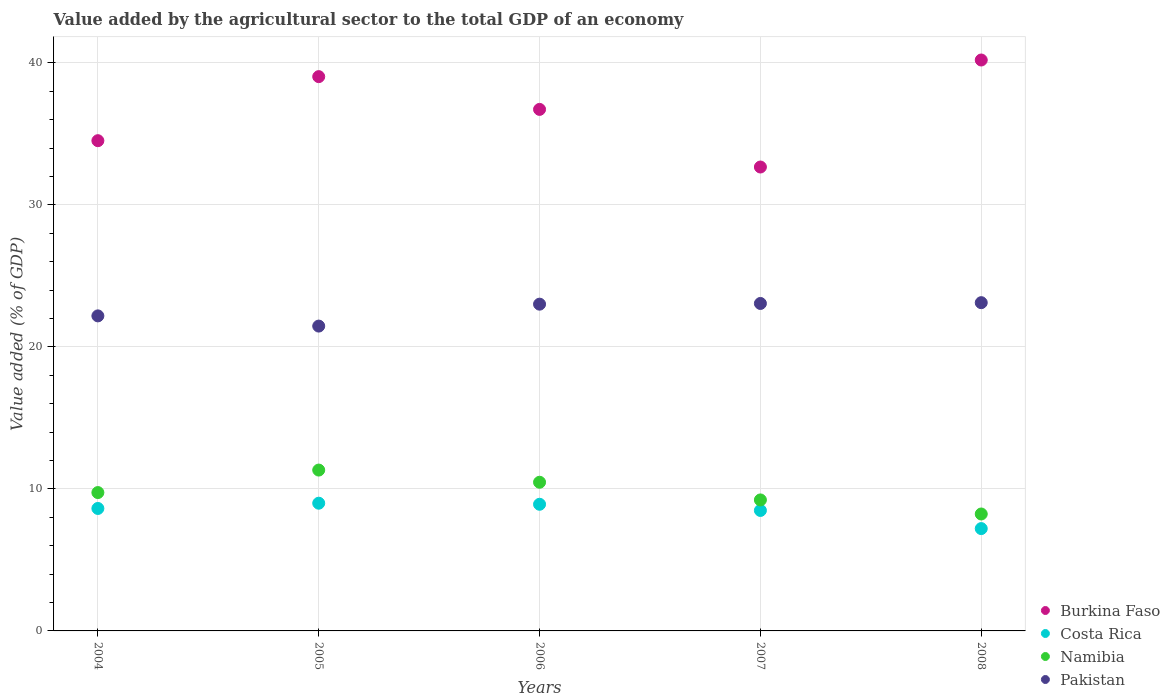How many different coloured dotlines are there?
Provide a succinct answer. 4. Is the number of dotlines equal to the number of legend labels?
Offer a very short reply. Yes. What is the value added by the agricultural sector to the total GDP in Namibia in 2004?
Make the answer very short. 9.74. Across all years, what is the maximum value added by the agricultural sector to the total GDP in Pakistan?
Make the answer very short. 23.11. Across all years, what is the minimum value added by the agricultural sector to the total GDP in Burkina Faso?
Offer a very short reply. 32.67. In which year was the value added by the agricultural sector to the total GDP in Namibia minimum?
Make the answer very short. 2008. What is the total value added by the agricultural sector to the total GDP in Burkina Faso in the graph?
Make the answer very short. 183.14. What is the difference between the value added by the agricultural sector to the total GDP in Burkina Faso in 2007 and that in 2008?
Offer a terse response. -7.54. What is the difference between the value added by the agricultural sector to the total GDP in Burkina Faso in 2008 and the value added by the agricultural sector to the total GDP in Pakistan in 2007?
Make the answer very short. 17.14. What is the average value added by the agricultural sector to the total GDP in Pakistan per year?
Give a very brief answer. 22.57. In the year 2006, what is the difference between the value added by the agricultural sector to the total GDP in Pakistan and value added by the agricultural sector to the total GDP in Costa Rica?
Your response must be concise. 14.09. In how many years, is the value added by the agricultural sector to the total GDP in Costa Rica greater than 38 %?
Your answer should be compact. 0. What is the ratio of the value added by the agricultural sector to the total GDP in Burkina Faso in 2006 to that in 2008?
Your answer should be very brief. 0.91. Is the value added by the agricultural sector to the total GDP in Namibia in 2005 less than that in 2007?
Your answer should be compact. No. What is the difference between the highest and the second highest value added by the agricultural sector to the total GDP in Pakistan?
Provide a succinct answer. 0.06. What is the difference between the highest and the lowest value added by the agricultural sector to the total GDP in Namibia?
Offer a very short reply. 3.09. Is the value added by the agricultural sector to the total GDP in Costa Rica strictly less than the value added by the agricultural sector to the total GDP in Pakistan over the years?
Your answer should be compact. Yes. What is the difference between two consecutive major ticks on the Y-axis?
Keep it short and to the point. 10. Are the values on the major ticks of Y-axis written in scientific E-notation?
Provide a short and direct response. No. Does the graph contain grids?
Your answer should be very brief. Yes. How are the legend labels stacked?
Provide a succinct answer. Vertical. What is the title of the graph?
Your answer should be compact. Value added by the agricultural sector to the total GDP of an economy. What is the label or title of the Y-axis?
Make the answer very short. Value added (% of GDP). What is the Value added (% of GDP) in Burkina Faso in 2004?
Provide a succinct answer. 34.52. What is the Value added (% of GDP) of Costa Rica in 2004?
Keep it short and to the point. 8.62. What is the Value added (% of GDP) of Namibia in 2004?
Keep it short and to the point. 9.74. What is the Value added (% of GDP) of Pakistan in 2004?
Keep it short and to the point. 22.18. What is the Value added (% of GDP) of Burkina Faso in 2005?
Your response must be concise. 39.03. What is the Value added (% of GDP) in Costa Rica in 2005?
Offer a terse response. 8.99. What is the Value added (% of GDP) in Namibia in 2005?
Provide a succinct answer. 11.33. What is the Value added (% of GDP) of Pakistan in 2005?
Ensure brevity in your answer.  21.47. What is the Value added (% of GDP) in Burkina Faso in 2006?
Your answer should be very brief. 36.72. What is the Value added (% of GDP) in Costa Rica in 2006?
Provide a succinct answer. 8.92. What is the Value added (% of GDP) in Namibia in 2006?
Make the answer very short. 10.47. What is the Value added (% of GDP) of Pakistan in 2006?
Your response must be concise. 23.01. What is the Value added (% of GDP) of Burkina Faso in 2007?
Make the answer very short. 32.67. What is the Value added (% of GDP) of Costa Rica in 2007?
Offer a terse response. 8.48. What is the Value added (% of GDP) in Namibia in 2007?
Provide a short and direct response. 9.22. What is the Value added (% of GDP) in Pakistan in 2007?
Keep it short and to the point. 23.06. What is the Value added (% of GDP) in Burkina Faso in 2008?
Offer a very short reply. 40.2. What is the Value added (% of GDP) of Costa Rica in 2008?
Provide a succinct answer. 7.21. What is the Value added (% of GDP) in Namibia in 2008?
Keep it short and to the point. 8.23. What is the Value added (% of GDP) of Pakistan in 2008?
Ensure brevity in your answer.  23.11. Across all years, what is the maximum Value added (% of GDP) of Burkina Faso?
Your answer should be very brief. 40.2. Across all years, what is the maximum Value added (% of GDP) of Costa Rica?
Give a very brief answer. 8.99. Across all years, what is the maximum Value added (% of GDP) of Namibia?
Keep it short and to the point. 11.33. Across all years, what is the maximum Value added (% of GDP) in Pakistan?
Ensure brevity in your answer.  23.11. Across all years, what is the minimum Value added (% of GDP) of Burkina Faso?
Keep it short and to the point. 32.67. Across all years, what is the minimum Value added (% of GDP) of Costa Rica?
Provide a succinct answer. 7.21. Across all years, what is the minimum Value added (% of GDP) in Namibia?
Offer a terse response. 8.23. Across all years, what is the minimum Value added (% of GDP) in Pakistan?
Ensure brevity in your answer.  21.47. What is the total Value added (% of GDP) in Burkina Faso in the graph?
Give a very brief answer. 183.14. What is the total Value added (% of GDP) of Costa Rica in the graph?
Your response must be concise. 42.22. What is the total Value added (% of GDP) of Namibia in the graph?
Provide a succinct answer. 49. What is the total Value added (% of GDP) of Pakistan in the graph?
Your answer should be compact. 112.83. What is the difference between the Value added (% of GDP) of Burkina Faso in 2004 and that in 2005?
Ensure brevity in your answer.  -4.51. What is the difference between the Value added (% of GDP) of Costa Rica in 2004 and that in 2005?
Your response must be concise. -0.37. What is the difference between the Value added (% of GDP) in Namibia in 2004 and that in 2005?
Your response must be concise. -1.58. What is the difference between the Value added (% of GDP) in Pakistan in 2004 and that in 2005?
Offer a very short reply. 0.72. What is the difference between the Value added (% of GDP) of Burkina Faso in 2004 and that in 2006?
Provide a short and direct response. -2.2. What is the difference between the Value added (% of GDP) of Costa Rica in 2004 and that in 2006?
Your answer should be very brief. -0.29. What is the difference between the Value added (% of GDP) of Namibia in 2004 and that in 2006?
Ensure brevity in your answer.  -0.73. What is the difference between the Value added (% of GDP) of Pakistan in 2004 and that in 2006?
Provide a short and direct response. -0.83. What is the difference between the Value added (% of GDP) of Burkina Faso in 2004 and that in 2007?
Ensure brevity in your answer.  1.85. What is the difference between the Value added (% of GDP) of Costa Rica in 2004 and that in 2007?
Provide a succinct answer. 0.14. What is the difference between the Value added (% of GDP) of Namibia in 2004 and that in 2007?
Give a very brief answer. 0.52. What is the difference between the Value added (% of GDP) in Pakistan in 2004 and that in 2007?
Offer a very short reply. -0.87. What is the difference between the Value added (% of GDP) in Burkina Faso in 2004 and that in 2008?
Ensure brevity in your answer.  -5.68. What is the difference between the Value added (% of GDP) in Costa Rica in 2004 and that in 2008?
Offer a very short reply. 1.42. What is the difference between the Value added (% of GDP) in Namibia in 2004 and that in 2008?
Make the answer very short. 1.51. What is the difference between the Value added (% of GDP) of Pakistan in 2004 and that in 2008?
Your answer should be compact. -0.93. What is the difference between the Value added (% of GDP) in Burkina Faso in 2005 and that in 2006?
Ensure brevity in your answer.  2.31. What is the difference between the Value added (% of GDP) in Costa Rica in 2005 and that in 2006?
Provide a short and direct response. 0.08. What is the difference between the Value added (% of GDP) in Namibia in 2005 and that in 2006?
Ensure brevity in your answer.  0.86. What is the difference between the Value added (% of GDP) of Pakistan in 2005 and that in 2006?
Offer a very short reply. -1.54. What is the difference between the Value added (% of GDP) in Burkina Faso in 2005 and that in 2007?
Your answer should be compact. 6.36. What is the difference between the Value added (% of GDP) of Costa Rica in 2005 and that in 2007?
Give a very brief answer. 0.51. What is the difference between the Value added (% of GDP) in Namibia in 2005 and that in 2007?
Provide a succinct answer. 2.1. What is the difference between the Value added (% of GDP) of Pakistan in 2005 and that in 2007?
Give a very brief answer. -1.59. What is the difference between the Value added (% of GDP) of Burkina Faso in 2005 and that in 2008?
Your answer should be very brief. -1.17. What is the difference between the Value added (% of GDP) in Costa Rica in 2005 and that in 2008?
Your answer should be compact. 1.79. What is the difference between the Value added (% of GDP) in Namibia in 2005 and that in 2008?
Offer a very short reply. 3.09. What is the difference between the Value added (% of GDP) of Pakistan in 2005 and that in 2008?
Offer a terse response. -1.65. What is the difference between the Value added (% of GDP) of Burkina Faso in 2006 and that in 2007?
Make the answer very short. 4.06. What is the difference between the Value added (% of GDP) in Costa Rica in 2006 and that in 2007?
Give a very brief answer. 0.44. What is the difference between the Value added (% of GDP) in Namibia in 2006 and that in 2007?
Provide a succinct answer. 1.24. What is the difference between the Value added (% of GDP) in Pakistan in 2006 and that in 2007?
Your answer should be very brief. -0.05. What is the difference between the Value added (% of GDP) of Burkina Faso in 2006 and that in 2008?
Keep it short and to the point. -3.48. What is the difference between the Value added (% of GDP) in Costa Rica in 2006 and that in 2008?
Your response must be concise. 1.71. What is the difference between the Value added (% of GDP) of Namibia in 2006 and that in 2008?
Offer a very short reply. 2.24. What is the difference between the Value added (% of GDP) in Pakistan in 2006 and that in 2008?
Your answer should be compact. -0.1. What is the difference between the Value added (% of GDP) of Burkina Faso in 2007 and that in 2008?
Give a very brief answer. -7.54. What is the difference between the Value added (% of GDP) of Costa Rica in 2007 and that in 2008?
Your answer should be very brief. 1.28. What is the difference between the Value added (% of GDP) of Pakistan in 2007 and that in 2008?
Make the answer very short. -0.06. What is the difference between the Value added (% of GDP) of Burkina Faso in 2004 and the Value added (% of GDP) of Costa Rica in 2005?
Provide a succinct answer. 25.53. What is the difference between the Value added (% of GDP) in Burkina Faso in 2004 and the Value added (% of GDP) in Namibia in 2005?
Your answer should be compact. 23.19. What is the difference between the Value added (% of GDP) in Burkina Faso in 2004 and the Value added (% of GDP) in Pakistan in 2005?
Ensure brevity in your answer.  13.06. What is the difference between the Value added (% of GDP) of Costa Rica in 2004 and the Value added (% of GDP) of Namibia in 2005?
Provide a short and direct response. -2.7. What is the difference between the Value added (% of GDP) in Costa Rica in 2004 and the Value added (% of GDP) in Pakistan in 2005?
Give a very brief answer. -12.84. What is the difference between the Value added (% of GDP) in Namibia in 2004 and the Value added (% of GDP) in Pakistan in 2005?
Provide a succinct answer. -11.72. What is the difference between the Value added (% of GDP) in Burkina Faso in 2004 and the Value added (% of GDP) in Costa Rica in 2006?
Ensure brevity in your answer.  25.6. What is the difference between the Value added (% of GDP) in Burkina Faso in 2004 and the Value added (% of GDP) in Namibia in 2006?
Provide a succinct answer. 24.05. What is the difference between the Value added (% of GDP) of Burkina Faso in 2004 and the Value added (% of GDP) of Pakistan in 2006?
Offer a terse response. 11.51. What is the difference between the Value added (% of GDP) of Costa Rica in 2004 and the Value added (% of GDP) of Namibia in 2006?
Provide a short and direct response. -1.85. What is the difference between the Value added (% of GDP) of Costa Rica in 2004 and the Value added (% of GDP) of Pakistan in 2006?
Offer a very short reply. -14.39. What is the difference between the Value added (% of GDP) of Namibia in 2004 and the Value added (% of GDP) of Pakistan in 2006?
Your response must be concise. -13.27. What is the difference between the Value added (% of GDP) of Burkina Faso in 2004 and the Value added (% of GDP) of Costa Rica in 2007?
Your answer should be very brief. 26.04. What is the difference between the Value added (% of GDP) of Burkina Faso in 2004 and the Value added (% of GDP) of Namibia in 2007?
Your answer should be very brief. 25.3. What is the difference between the Value added (% of GDP) of Burkina Faso in 2004 and the Value added (% of GDP) of Pakistan in 2007?
Provide a succinct answer. 11.46. What is the difference between the Value added (% of GDP) in Costa Rica in 2004 and the Value added (% of GDP) in Namibia in 2007?
Provide a succinct answer. -0.6. What is the difference between the Value added (% of GDP) of Costa Rica in 2004 and the Value added (% of GDP) of Pakistan in 2007?
Ensure brevity in your answer.  -14.44. What is the difference between the Value added (% of GDP) of Namibia in 2004 and the Value added (% of GDP) of Pakistan in 2007?
Your response must be concise. -13.32. What is the difference between the Value added (% of GDP) in Burkina Faso in 2004 and the Value added (% of GDP) in Costa Rica in 2008?
Ensure brevity in your answer.  27.32. What is the difference between the Value added (% of GDP) of Burkina Faso in 2004 and the Value added (% of GDP) of Namibia in 2008?
Provide a short and direct response. 26.29. What is the difference between the Value added (% of GDP) in Burkina Faso in 2004 and the Value added (% of GDP) in Pakistan in 2008?
Your answer should be compact. 11.41. What is the difference between the Value added (% of GDP) in Costa Rica in 2004 and the Value added (% of GDP) in Namibia in 2008?
Make the answer very short. 0.39. What is the difference between the Value added (% of GDP) of Costa Rica in 2004 and the Value added (% of GDP) of Pakistan in 2008?
Your response must be concise. -14.49. What is the difference between the Value added (% of GDP) of Namibia in 2004 and the Value added (% of GDP) of Pakistan in 2008?
Give a very brief answer. -13.37. What is the difference between the Value added (% of GDP) of Burkina Faso in 2005 and the Value added (% of GDP) of Costa Rica in 2006?
Ensure brevity in your answer.  30.11. What is the difference between the Value added (% of GDP) of Burkina Faso in 2005 and the Value added (% of GDP) of Namibia in 2006?
Offer a very short reply. 28.56. What is the difference between the Value added (% of GDP) of Burkina Faso in 2005 and the Value added (% of GDP) of Pakistan in 2006?
Your response must be concise. 16.02. What is the difference between the Value added (% of GDP) in Costa Rica in 2005 and the Value added (% of GDP) in Namibia in 2006?
Provide a succinct answer. -1.48. What is the difference between the Value added (% of GDP) in Costa Rica in 2005 and the Value added (% of GDP) in Pakistan in 2006?
Make the answer very short. -14.02. What is the difference between the Value added (% of GDP) of Namibia in 2005 and the Value added (% of GDP) of Pakistan in 2006?
Your answer should be compact. -11.68. What is the difference between the Value added (% of GDP) of Burkina Faso in 2005 and the Value added (% of GDP) of Costa Rica in 2007?
Give a very brief answer. 30.55. What is the difference between the Value added (% of GDP) in Burkina Faso in 2005 and the Value added (% of GDP) in Namibia in 2007?
Keep it short and to the point. 29.81. What is the difference between the Value added (% of GDP) of Burkina Faso in 2005 and the Value added (% of GDP) of Pakistan in 2007?
Provide a short and direct response. 15.97. What is the difference between the Value added (% of GDP) of Costa Rica in 2005 and the Value added (% of GDP) of Namibia in 2007?
Provide a short and direct response. -0.23. What is the difference between the Value added (% of GDP) of Costa Rica in 2005 and the Value added (% of GDP) of Pakistan in 2007?
Make the answer very short. -14.06. What is the difference between the Value added (% of GDP) of Namibia in 2005 and the Value added (% of GDP) of Pakistan in 2007?
Provide a short and direct response. -11.73. What is the difference between the Value added (% of GDP) in Burkina Faso in 2005 and the Value added (% of GDP) in Costa Rica in 2008?
Your response must be concise. 31.83. What is the difference between the Value added (% of GDP) in Burkina Faso in 2005 and the Value added (% of GDP) in Namibia in 2008?
Keep it short and to the point. 30.8. What is the difference between the Value added (% of GDP) of Burkina Faso in 2005 and the Value added (% of GDP) of Pakistan in 2008?
Offer a terse response. 15.92. What is the difference between the Value added (% of GDP) of Costa Rica in 2005 and the Value added (% of GDP) of Namibia in 2008?
Keep it short and to the point. 0.76. What is the difference between the Value added (% of GDP) in Costa Rica in 2005 and the Value added (% of GDP) in Pakistan in 2008?
Offer a terse response. -14.12. What is the difference between the Value added (% of GDP) in Namibia in 2005 and the Value added (% of GDP) in Pakistan in 2008?
Provide a short and direct response. -11.79. What is the difference between the Value added (% of GDP) in Burkina Faso in 2006 and the Value added (% of GDP) in Costa Rica in 2007?
Offer a terse response. 28.24. What is the difference between the Value added (% of GDP) in Burkina Faso in 2006 and the Value added (% of GDP) in Namibia in 2007?
Make the answer very short. 27.5. What is the difference between the Value added (% of GDP) in Burkina Faso in 2006 and the Value added (% of GDP) in Pakistan in 2007?
Provide a succinct answer. 13.67. What is the difference between the Value added (% of GDP) of Costa Rica in 2006 and the Value added (% of GDP) of Namibia in 2007?
Provide a short and direct response. -0.31. What is the difference between the Value added (% of GDP) in Costa Rica in 2006 and the Value added (% of GDP) in Pakistan in 2007?
Your answer should be very brief. -14.14. What is the difference between the Value added (% of GDP) in Namibia in 2006 and the Value added (% of GDP) in Pakistan in 2007?
Your response must be concise. -12.59. What is the difference between the Value added (% of GDP) in Burkina Faso in 2006 and the Value added (% of GDP) in Costa Rica in 2008?
Give a very brief answer. 29.52. What is the difference between the Value added (% of GDP) in Burkina Faso in 2006 and the Value added (% of GDP) in Namibia in 2008?
Your response must be concise. 28.49. What is the difference between the Value added (% of GDP) of Burkina Faso in 2006 and the Value added (% of GDP) of Pakistan in 2008?
Your answer should be compact. 13.61. What is the difference between the Value added (% of GDP) of Costa Rica in 2006 and the Value added (% of GDP) of Namibia in 2008?
Provide a succinct answer. 0.68. What is the difference between the Value added (% of GDP) in Costa Rica in 2006 and the Value added (% of GDP) in Pakistan in 2008?
Make the answer very short. -14.2. What is the difference between the Value added (% of GDP) in Namibia in 2006 and the Value added (% of GDP) in Pakistan in 2008?
Provide a succinct answer. -12.65. What is the difference between the Value added (% of GDP) of Burkina Faso in 2007 and the Value added (% of GDP) of Costa Rica in 2008?
Offer a very short reply. 25.46. What is the difference between the Value added (% of GDP) of Burkina Faso in 2007 and the Value added (% of GDP) of Namibia in 2008?
Give a very brief answer. 24.43. What is the difference between the Value added (% of GDP) of Burkina Faso in 2007 and the Value added (% of GDP) of Pakistan in 2008?
Provide a succinct answer. 9.55. What is the difference between the Value added (% of GDP) of Costa Rica in 2007 and the Value added (% of GDP) of Namibia in 2008?
Keep it short and to the point. 0.25. What is the difference between the Value added (% of GDP) of Costa Rica in 2007 and the Value added (% of GDP) of Pakistan in 2008?
Your answer should be compact. -14.63. What is the difference between the Value added (% of GDP) in Namibia in 2007 and the Value added (% of GDP) in Pakistan in 2008?
Offer a terse response. -13.89. What is the average Value added (% of GDP) in Burkina Faso per year?
Ensure brevity in your answer.  36.63. What is the average Value added (% of GDP) in Costa Rica per year?
Your response must be concise. 8.44. What is the average Value added (% of GDP) of Namibia per year?
Provide a succinct answer. 9.8. What is the average Value added (% of GDP) of Pakistan per year?
Ensure brevity in your answer.  22.57. In the year 2004, what is the difference between the Value added (% of GDP) in Burkina Faso and Value added (% of GDP) in Costa Rica?
Keep it short and to the point. 25.9. In the year 2004, what is the difference between the Value added (% of GDP) of Burkina Faso and Value added (% of GDP) of Namibia?
Keep it short and to the point. 24.78. In the year 2004, what is the difference between the Value added (% of GDP) of Burkina Faso and Value added (% of GDP) of Pakistan?
Offer a terse response. 12.34. In the year 2004, what is the difference between the Value added (% of GDP) in Costa Rica and Value added (% of GDP) in Namibia?
Provide a succinct answer. -1.12. In the year 2004, what is the difference between the Value added (% of GDP) in Costa Rica and Value added (% of GDP) in Pakistan?
Make the answer very short. -13.56. In the year 2004, what is the difference between the Value added (% of GDP) of Namibia and Value added (% of GDP) of Pakistan?
Offer a very short reply. -12.44. In the year 2005, what is the difference between the Value added (% of GDP) of Burkina Faso and Value added (% of GDP) of Costa Rica?
Offer a very short reply. 30.04. In the year 2005, what is the difference between the Value added (% of GDP) in Burkina Faso and Value added (% of GDP) in Namibia?
Offer a terse response. 27.7. In the year 2005, what is the difference between the Value added (% of GDP) in Burkina Faso and Value added (% of GDP) in Pakistan?
Keep it short and to the point. 17.57. In the year 2005, what is the difference between the Value added (% of GDP) in Costa Rica and Value added (% of GDP) in Namibia?
Offer a very short reply. -2.33. In the year 2005, what is the difference between the Value added (% of GDP) in Costa Rica and Value added (% of GDP) in Pakistan?
Make the answer very short. -12.47. In the year 2005, what is the difference between the Value added (% of GDP) of Namibia and Value added (% of GDP) of Pakistan?
Your response must be concise. -10.14. In the year 2006, what is the difference between the Value added (% of GDP) of Burkina Faso and Value added (% of GDP) of Costa Rica?
Offer a terse response. 27.81. In the year 2006, what is the difference between the Value added (% of GDP) of Burkina Faso and Value added (% of GDP) of Namibia?
Keep it short and to the point. 26.25. In the year 2006, what is the difference between the Value added (% of GDP) in Burkina Faso and Value added (% of GDP) in Pakistan?
Provide a succinct answer. 13.71. In the year 2006, what is the difference between the Value added (% of GDP) of Costa Rica and Value added (% of GDP) of Namibia?
Keep it short and to the point. -1.55. In the year 2006, what is the difference between the Value added (% of GDP) in Costa Rica and Value added (% of GDP) in Pakistan?
Offer a terse response. -14.09. In the year 2006, what is the difference between the Value added (% of GDP) of Namibia and Value added (% of GDP) of Pakistan?
Your response must be concise. -12.54. In the year 2007, what is the difference between the Value added (% of GDP) of Burkina Faso and Value added (% of GDP) of Costa Rica?
Provide a short and direct response. 24.18. In the year 2007, what is the difference between the Value added (% of GDP) of Burkina Faso and Value added (% of GDP) of Namibia?
Offer a very short reply. 23.44. In the year 2007, what is the difference between the Value added (% of GDP) of Burkina Faso and Value added (% of GDP) of Pakistan?
Your answer should be compact. 9.61. In the year 2007, what is the difference between the Value added (% of GDP) of Costa Rica and Value added (% of GDP) of Namibia?
Give a very brief answer. -0.74. In the year 2007, what is the difference between the Value added (% of GDP) of Costa Rica and Value added (% of GDP) of Pakistan?
Make the answer very short. -14.58. In the year 2007, what is the difference between the Value added (% of GDP) of Namibia and Value added (% of GDP) of Pakistan?
Provide a short and direct response. -13.83. In the year 2008, what is the difference between the Value added (% of GDP) in Burkina Faso and Value added (% of GDP) in Costa Rica?
Offer a terse response. 33. In the year 2008, what is the difference between the Value added (% of GDP) of Burkina Faso and Value added (% of GDP) of Namibia?
Your response must be concise. 31.97. In the year 2008, what is the difference between the Value added (% of GDP) of Burkina Faso and Value added (% of GDP) of Pakistan?
Keep it short and to the point. 17.09. In the year 2008, what is the difference between the Value added (% of GDP) in Costa Rica and Value added (% of GDP) in Namibia?
Your answer should be compact. -1.03. In the year 2008, what is the difference between the Value added (% of GDP) of Costa Rica and Value added (% of GDP) of Pakistan?
Your answer should be compact. -15.91. In the year 2008, what is the difference between the Value added (% of GDP) of Namibia and Value added (% of GDP) of Pakistan?
Keep it short and to the point. -14.88. What is the ratio of the Value added (% of GDP) in Burkina Faso in 2004 to that in 2005?
Your answer should be compact. 0.88. What is the ratio of the Value added (% of GDP) of Costa Rica in 2004 to that in 2005?
Provide a short and direct response. 0.96. What is the ratio of the Value added (% of GDP) of Namibia in 2004 to that in 2005?
Your response must be concise. 0.86. What is the ratio of the Value added (% of GDP) of Pakistan in 2004 to that in 2005?
Offer a terse response. 1.03. What is the ratio of the Value added (% of GDP) of Burkina Faso in 2004 to that in 2006?
Provide a short and direct response. 0.94. What is the ratio of the Value added (% of GDP) in Namibia in 2004 to that in 2006?
Offer a very short reply. 0.93. What is the ratio of the Value added (% of GDP) of Pakistan in 2004 to that in 2006?
Give a very brief answer. 0.96. What is the ratio of the Value added (% of GDP) of Burkina Faso in 2004 to that in 2007?
Offer a terse response. 1.06. What is the ratio of the Value added (% of GDP) in Costa Rica in 2004 to that in 2007?
Offer a terse response. 1.02. What is the ratio of the Value added (% of GDP) in Namibia in 2004 to that in 2007?
Make the answer very short. 1.06. What is the ratio of the Value added (% of GDP) in Pakistan in 2004 to that in 2007?
Provide a short and direct response. 0.96. What is the ratio of the Value added (% of GDP) in Burkina Faso in 2004 to that in 2008?
Provide a short and direct response. 0.86. What is the ratio of the Value added (% of GDP) of Costa Rica in 2004 to that in 2008?
Provide a short and direct response. 1.2. What is the ratio of the Value added (% of GDP) of Namibia in 2004 to that in 2008?
Give a very brief answer. 1.18. What is the ratio of the Value added (% of GDP) of Pakistan in 2004 to that in 2008?
Provide a short and direct response. 0.96. What is the ratio of the Value added (% of GDP) of Burkina Faso in 2005 to that in 2006?
Provide a short and direct response. 1.06. What is the ratio of the Value added (% of GDP) of Costa Rica in 2005 to that in 2006?
Your answer should be compact. 1.01. What is the ratio of the Value added (% of GDP) of Namibia in 2005 to that in 2006?
Your response must be concise. 1.08. What is the ratio of the Value added (% of GDP) in Pakistan in 2005 to that in 2006?
Ensure brevity in your answer.  0.93. What is the ratio of the Value added (% of GDP) in Burkina Faso in 2005 to that in 2007?
Ensure brevity in your answer.  1.19. What is the ratio of the Value added (% of GDP) of Costa Rica in 2005 to that in 2007?
Your answer should be very brief. 1.06. What is the ratio of the Value added (% of GDP) of Namibia in 2005 to that in 2007?
Give a very brief answer. 1.23. What is the ratio of the Value added (% of GDP) of Pakistan in 2005 to that in 2007?
Make the answer very short. 0.93. What is the ratio of the Value added (% of GDP) in Burkina Faso in 2005 to that in 2008?
Keep it short and to the point. 0.97. What is the ratio of the Value added (% of GDP) of Costa Rica in 2005 to that in 2008?
Give a very brief answer. 1.25. What is the ratio of the Value added (% of GDP) in Namibia in 2005 to that in 2008?
Your response must be concise. 1.38. What is the ratio of the Value added (% of GDP) in Pakistan in 2005 to that in 2008?
Keep it short and to the point. 0.93. What is the ratio of the Value added (% of GDP) of Burkina Faso in 2006 to that in 2007?
Keep it short and to the point. 1.12. What is the ratio of the Value added (% of GDP) in Costa Rica in 2006 to that in 2007?
Provide a short and direct response. 1.05. What is the ratio of the Value added (% of GDP) of Namibia in 2006 to that in 2007?
Your answer should be compact. 1.13. What is the ratio of the Value added (% of GDP) in Burkina Faso in 2006 to that in 2008?
Provide a succinct answer. 0.91. What is the ratio of the Value added (% of GDP) of Costa Rica in 2006 to that in 2008?
Provide a short and direct response. 1.24. What is the ratio of the Value added (% of GDP) of Namibia in 2006 to that in 2008?
Your answer should be very brief. 1.27. What is the ratio of the Value added (% of GDP) in Burkina Faso in 2007 to that in 2008?
Provide a succinct answer. 0.81. What is the ratio of the Value added (% of GDP) in Costa Rica in 2007 to that in 2008?
Keep it short and to the point. 1.18. What is the ratio of the Value added (% of GDP) in Namibia in 2007 to that in 2008?
Offer a very short reply. 1.12. What is the ratio of the Value added (% of GDP) of Pakistan in 2007 to that in 2008?
Your answer should be very brief. 1. What is the difference between the highest and the second highest Value added (% of GDP) of Burkina Faso?
Make the answer very short. 1.17. What is the difference between the highest and the second highest Value added (% of GDP) in Costa Rica?
Your response must be concise. 0.08. What is the difference between the highest and the second highest Value added (% of GDP) in Namibia?
Give a very brief answer. 0.86. What is the difference between the highest and the second highest Value added (% of GDP) of Pakistan?
Offer a very short reply. 0.06. What is the difference between the highest and the lowest Value added (% of GDP) in Burkina Faso?
Your answer should be compact. 7.54. What is the difference between the highest and the lowest Value added (% of GDP) in Costa Rica?
Provide a short and direct response. 1.79. What is the difference between the highest and the lowest Value added (% of GDP) in Namibia?
Your answer should be very brief. 3.09. What is the difference between the highest and the lowest Value added (% of GDP) of Pakistan?
Offer a very short reply. 1.65. 